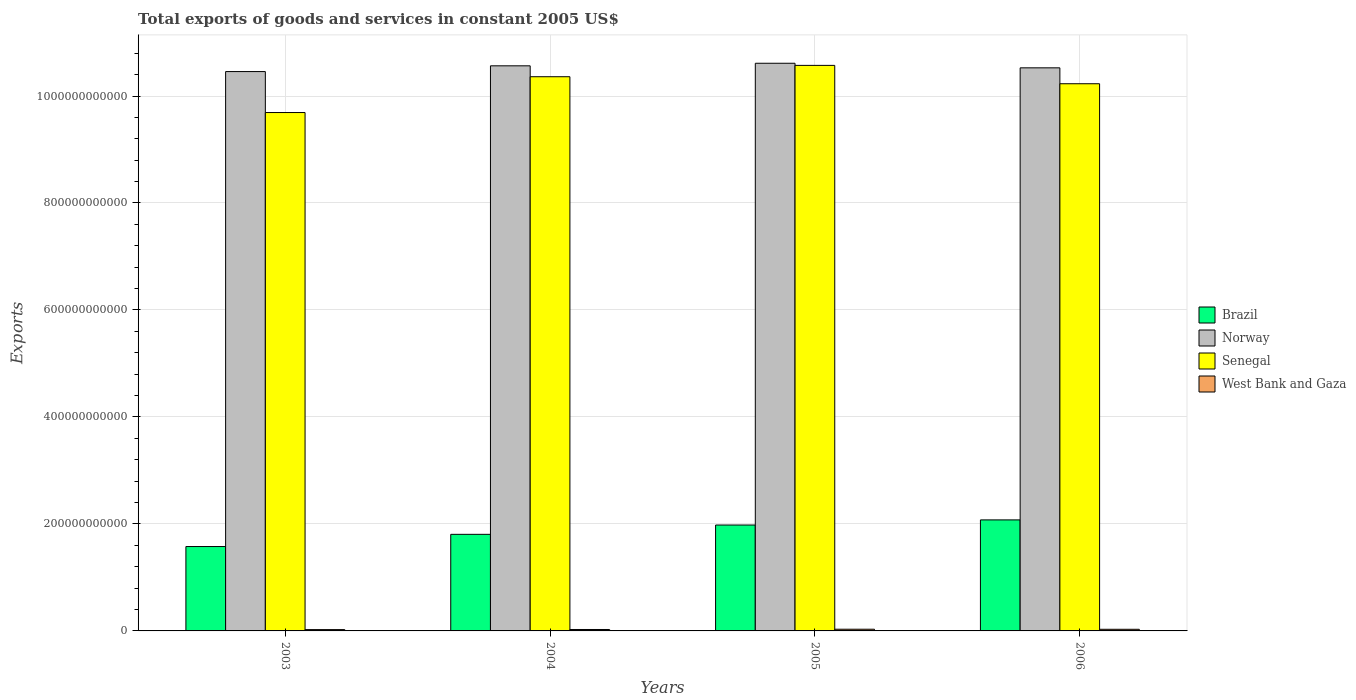How many groups of bars are there?
Give a very brief answer. 4. How many bars are there on the 2nd tick from the left?
Give a very brief answer. 4. How many bars are there on the 1st tick from the right?
Give a very brief answer. 4. What is the total exports of goods and services in Senegal in 2004?
Your response must be concise. 1.04e+12. Across all years, what is the maximum total exports of goods and services in Brazil?
Offer a very short reply. 2.08e+11. Across all years, what is the minimum total exports of goods and services in Brazil?
Keep it short and to the point. 1.58e+11. In which year was the total exports of goods and services in Senegal maximum?
Provide a short and direct response. 2005. What is the total total exports of goods and services in Senegal in the graph?
Provide a short and direct response. 4.09e+12. What is the difference between the total exports of goods and services in Norway in 2003 and that in 2004?
Keep it short and to the point. -1.08e+1. What is the difference between the total exports of goods and services in Norway in 2005 and the total exports of goods and services in Brazil in 2004?
Your answer should be very brief. 8.81e+11. What is the average total exports of goods and services in Brazil per year?
Your response must be concise. 1.86e+11. In the year 2006, what is the difference between the total exports of goods and services in Brazil and total exports of goods and services in West Bank and Gaza?
Make the answer very short. 2.05e+11. What is the ratio of the total exports of goods and services in Norway in 2003 to that in 2005?
Ensure brevity in your answer.  0.99. What is the difference between the highest and the second highest total exports of goods and services in Brazil?
Your response must be concise. 9.58e+09. What is the difference between the highest and the lowest total exports of goods and services in Norway?
Give a very brief answer. 1.55e+1. Is it the case that in every year, the sum of the total exports of goods and services in West Bank and Gaza and total exports of goods and services in Brazil is greater than the sum of total exports of goods and services in Norway and total exports of goods and services in Senegal?
Your answer should be compact. Yes. What does the 3rd bar from the right in 2003 represents?
Your response must be concise. Norway. What is the difference between two consecutive major ticks on the Y-axis?
Keep it short and to the point. 2.00e+11. Are the values on the major ticks of Y-axis written in scientific E-notation?
Your response must be concise. No. Does the graph contain any zero values?
Offer a terse response. No. Does the graph contain grids?
Your response must be concise. Yes. How many legend labels are there?
Offer a terse response. 4. How are the legend labels stacked?
Your response must be concise. Vertical. What is the title of the graph?
Make the answer very short. Total exports of goods and services in constant 2005 US$. Does "Isle of Man" appear as one of the legend labels in the graph?
Offer a terse response. No. What is the label or title of the X-axis?
Ensure brevity in your answer.  Years. What is the label or title of the Y-axis?
Your response must be concise. Exports. What is the Exports of Brazil in 2003?
Offer a very short reply. 1.58e+11. What is the Exports in Norway in 2003?
Offer a very short reply. 1.05e+12. What is the Exports of Senegal in 2003?
Ensure brevity in your answer.  9.69e+11. What is the Exports of West Bank and Gaza in 2003?
Provide a succinct answer. 2.45e+09. What is the Exports in Brazil in 2004?
Make the answer very short. 1.81e+11. What is the Exports in Norway in 2004?
Your response must be concise. 1.06e+12. What is the Exports of Senegal in 2004?
Provide a succinct answer. 1.04e+12. What is the Exports in West Bank and Gaza in 2004?
Offer a terse response. 2.67e+09. What is the Exports in Brazil in 2005?
Provide a succinct answer. 1.98e+11. What is the Exports in Norway in 2005?
Your answer should be compact. 1.06e+12. What is the Exports of Senegal in 2005?
Make the answer very short. 1.06e+12. What is the Exports of West Bank and Gaza in 2005?
Your response must be concise. 3.16e+09. What is the Exports of Brazil in 2006?
Your response must be concise. 2.08e+11. What is the Exports in Norway in 2006?
Provide a succinct answer. 1.05e+12. What is the Exports in Senegal in 2006?
Ensure brevity in your answer.  1.02e+12. What is the Exports of West Bank and Gaza in 2006?
Offer a terse response. 3.05e+09. Across all years, what is the maximum Exports in Brazil?
Provide a succinct answer. 2.08e+11. Across all years, what is the maximum Exports in Norway?
Make the answer very short. 1.06e+12. Across all years, what is the maximum Exports in Senegal?
Your response must be concise. 1.06e+12. Across all years, what is the maximum Exports of West Bank and Gaza?
Ensure brevity in your answer.  3.16e+09. Across all years, what is the minimum Exports of Brazil?
Offer a terse response. 1.58e+11. Across all years, what is the minimum Exports in Norway?
Your response must be concise. 1.05e+12. Across all years, what is the minimum Exports in Senegal?
Give a very brief answer. 9.69e+11. Across all years, what is the minimum Exports in West Bank and Gaza?
Offer a terse response. 2.45e+09. What is the total Exports of Brazil in the graph?
Your answer should be very brief. 7.44e+11. What is the total Exports of Norway in the graph?
Give a very brief answer. 4.22e+12. What is the total Exports in Senegal in the graph?
Make the answer very short. 4.09e+12. What is the total Exports in West Bank and Gaza in the graph?
Your answer should be very brief. 1.13e+1. What is the difference between the Exports of Brazil in 2003 and that in 2004?
Your answer should be compact. -2.28e+1. What is the difference between the Exports in Norway in 2003 and that in 2004?
Your answer should be very brief. -1.08e+1. What is the difference between the Exports of Senegal in 2003 and that in 2004?
Give a very brief answer. -6.69e+1. What is the difference between the Exports in West Bank and Gaza in 2003 and that in 2004?
Ensure brevity in your answer.  -2.19e+08. What is the difference between the Exports of Brazil in 2003 and that in 2005?
Ensure brevity in your answer.  -4.02e+1. What is the difference between the Exports of Norway in 2003 and that in 2005?
Your response must be concise. -1.55e+1. What is the difference between the Exports of Senegal in 2003 and that in 2005?
Keep it short and to the point. -8.81e+1. What is the difference between the Exports in West Bank and Gaza in 2003 and that in 2005?
Provide a short and direct response. -7.08e+08. What is the difference between the Exports in Brazil in 2003 and that in 2006?
Make the answer very short. -4.98e+1. What is the difference between the Exports of Norway in 2003 and that in 2006?
Offer a terse response. -6.99e+09. What is the difference between the Exports in Senegal in 2003 and that in 2006?
Keep it short and to the point. -5.38e+1. What is the difference between the Exports in West Bank and Gaza in 2003 and that in 2006?
Provide a short and direct response. -5.94e+08. What is the difference between the Exports in Brazil in 2004 and that in 2005?
Your answer should be very brief. -1.74e+1. What is the difference between the Exports of Norway in 2004 and that in 2005?
Provide a short and direct response. -4.78e+09. What is the difference between the Exports in Senegal in 2004 and that in 2005?
Your answer should be compact. -2.12e+1. What is the difference between the Exports in West Bank and Gaza in 2004 and that in 2005?
Make the answer very short. -4.89e+08. What is the difference between the Exports in Brazil in 2004 and that in 2006?
Ensure brevity in your answer.  -2.70e+1. What is the difference between the Exports in Norway in 2004 and that in 2006?
Ensure brevity in your answer.  3.77e+09. What is the difference between the Exports of Senegal in 2004 and that in 2006?
Offer a terse response. 1.31e+1. What is the difference between the Exports in West Bank and Gaza in 2004 and that in 2006?
Your response must be concise. -3.74e+08. What is the difference between the Exports of Brazil in 2005 and that in 2006?
Your response must be concise. -9.58e+09. What is the difference between the Exports in Norway in 2005 and that in 2006?
Make the answer very short. 8.55e+09. What is the difference between the Exports in Senegal in 2005 and that in 2006?
Provide a succinct answer. 3.43e+1. What is the difference between the Exports of West Bank and Gaza in 2005 and that in 2006?
Your response must be concise. 1.15e+08. What is the difference between the Exports in Brazil in 2003 and the Exports in Norway in 2004?
Your answer should be compact. -8.99e+11. What is the difference between the Exports in Brazil in 2003 and the Exports in Senegal in 2004?
Your answer should be very brief. -8.78e+11. What is the difference between the Exports of Brazil in 2003 and the Exports of West Bank and Gaza in 2004?
Make the answer very short. 1.55e+11. What is the difference between the Exports in Norway in 2003 and the Exports in Senegal in 2004?
Offer a very short reply. 9.65e+09. What is the difference between the Exports of Norway in 2003 and the Exports of West Bank and Gaza in 2004?
Your answer should be compact. 1.04e+12. What is the difference between the Exports of Senegal in 2003 and the Exports of West Bank and Gaza in 2004?
Your answer should be very brief. 9.66e+11. What is the difference between the Exports of Brazil in 2003 and the Exports of Norway in 2005?
Ensure brevity in your answer.  -9.03e+11. What is the difference between the Exports of Brazil in 2003 and the Exports of Senegal in 2005?
Make the answer very short. -9.00e+11. What is the difference between the Exports in Brazil in 2003 and the Exports in West Bank and Gaza in 2005?
Your response must be concise. 1.55e+11. What is the difference between the Exports of Norway in 2003 and the Exports of Senegal in 2005?
Ensure brevity in your answer.  -1.16e+1. What is the difference between the Exports in Norway in 2003 and the Exports in West Bank and Gaza in 2005?
Offer a very short reply. 1.04e+12. What is the difference between the Exports in Senegal in 2003 and the Exports in West Bank and Gaza in 2005?
Offer a terse response. 9.66e+11. What is the difference between the Exports of Brazil in 2003 and the Exports of Norway in 2006?
Provide a short and direct response. -8.95e+11. What is the difference between the Exports in Brazil in 2003 and the Exports in Senegal in 2006?
Ensure brevity in your answer.  -8.65e+11. What is the difference between the Exports in Brazil in 2003 and the Exports in West Bank and Gaza in 2006?
Give a very brief answer. 1.55e+11. What is the difference between the Exports of Norway in 2003 and the Exports of Senegal in 2006?
Provide a short and direct response. 2.28e+1. What is the difference between the Exports of Norway in 2003 and the Exports of West Bank and Gaza in 2006?
Your answer should be very brief. 1.04e+12. What is the difference between the Exports in Senegal in 2003 and the Exports in West Bank and Gaza in 2006?
Keep it short and to the point. 9.66e+11. What is the difference between the Exports in Brazil in 2004 and the Exports in Norway in 2005?
Your response must be concise. -8.81e+11. What is the difference between the Exports of Brazil in 2004 and the Exports of Senegal in 2005?
Your answer should be compact. -8.77e+11. What is the difference between the Exports in Brazil in 2004 and the Exports in West Bank and Gaza in 2005?
Ensure brevity in your answer.  1.77e+11. What is the difference between the Exports of Norway in 2004 and the Exports of Senegal in 2005?
Your response must be concise. -8.08e+08. What is the difference between the Exports of Norway in 2004 and the Exports of West Bank and Gaza in 2005?
Give a very brief answer. 1.05e+12. What is the difference between the Exports of Senegal in 2004 and the Exports of West Bank and Gaza in 2005?
Your response must be concise. 1.03e+12. What is the difference between the Exports of Brazil in 2004 and the Exports of Norway in 2006?
Your answer should be very brief. -8.72e+11. What is the difference between the Exports of Brazil in 2004 and the Exports of Senegal in 2006?
Ensure brevity in your answer.  -8.42e+11. What is the difference between the Exports in Brazil in 2004 and the Exports in West Bank and Gaza in 2006?
Provide a succinct answer. 1.78e+11. What is the difference between the Exports in Norway in 2004 and the Exports in Senegal in 2006?
Your answer should be compact. 3.35e+1. What is the difference between the Exports in Norway in 2004 and the Exports in West Bank and Gaza in 2006?
Keep it short and to the point. 1.05e+12. What is the difference between the Exports of Senegal in 2004 and the Exports of West Bank and Gaza in 2006?
Offer a very short reply. 1.03e+12. What is the difference between the Exports in Brazil in 2005 and the Exports in Norway in 2006?
Provide a succinct answer. -8.55e+11. What is the difference between the Exports of Brazil in 2005 and the Exports of Senegal in 2006?
Your response must be concise. -8.25e+11. What is the difference between the Exports of Brazil in 2005 and the Exports of West Bank and Gaza in 2006?
Your answer should be very brief. 1.95e+11. What is the difference between the Exports in Norway in 2005 and the Exports in Senegal in 2006?
Your response must be concise. 3.83e+1. What is the difference between the Exports in Norway in 2005 and the Exports in West Bank and Gaza in 2006?
Your answer should be very brief. 1.06e+12. What is the difference between the Exports in Senegal in 2005 and the Exports in West Bank and Gaza in 2006?
Provide a short and direct response. 1.05e+12. What is the average Exports of Brazil per year?
Your answer should be compact. 1.86e+11. What is the average Exports of Norway per year?
Provide a succinct answer. 1.05e+12. What is the average Exports in Senegal per year?
Keep it short and to the point. 1.02e+12. What is the average Exports in West Bank and Gaza per year?
Your answer should be compact. 2.83e+09. In the year 2003, what is the difference between the Exports of Brazil and Exports of Norway?
Your answer should be very brief. -8.88e+11. In the year 2003, what is the difference between the Exports of Brazil and Exports of Senegal?
Ensure brevity in your answer.  -8.11e+11. In the year 2003, what is the difference between the Exports in Brazil and Exports in West Bank and Gaza?
Make the answer very short. 1.55e+11. In the year 2003, what is the difference between the Exports in Norway and Exports in Senegal?
Your response must be concise. 7.66e+1. In the year 2003, what is the difference between the Exports of Norway and Exports of West Bank and Gaza?
Your response must be concise. 1.04e+12. In the year 2003, what is the difference between the Exports in Senegal and Exports in West Bank and Gaza?
Your answer should be compact. 9.67e+11. In the year 2004, what is the difference between the Exports of Brazil and Exports of Norway?
Give a very brief answer. -8.76e+11. In the year 2004, what is the difference between the Exports of Brazil and Exports of Senegal?
Offer a very short reply. -8.55e+11. In the year 2004, what is the difference between the Exports of Brazil and Exports of West Bank and Gaza?
Your answer should be compact. 1.78e+11. In the year 2004, what is the difference between the Exports in Norway and Exports in Senegal?
Provide a succinct answer. 2.04e+1. In the year 2004, what is the difference between the Exports in Norway and Exports in West Bank and Gaza?
Ensure brevity in your answer.  1.05e+12. In the year 2004, what is the difference between the Exports of Senegal and Exports of West Bank and Gaza?
Give a very brief answer. 1.03e+12. In the year 2005, what is the difference between the Exports of Brazil and Exports of Norway?
Your answer should be very brief. -8.63e+11. In the year 2005, what is the difference between the Exports in Brazil and Exports in Senegal?
Offer a terse response. -8.59e+11. In the year 2005, what is the difference between the Exports of Brazil and Exports of West Bank and Gaza?
Offer a terse response. 1.95e+11. In the year 2005, what is the difference between the Exports of Norway and Exports of Senegal?
Give a very brief answer. 3.97e+09. In the year 2005, what is the difference between the Exports in Norway and Exports in West Bank and Gaza?
Your answer should be very brief. 1.06e+12. In the year 2005, what is the difference between the Exports in Senegal and Exports in West Bank and Gaza?
Your response must be concise. 1.05e+12. In the year 2006, what is the difference between the Exports of Brazil and Exports of Norway?
Provide a short and direct response. -8.45e+11. In the year 2006, what is the difference between the Exports in Brazil and Exports in Senegal?
Give a very brief answer. -8.15e+11. In the year 2006, what is the difference between the Exports of Brazil and Exports of West Bank and Gaza?
Keep it short and to the point. 2.05e+11. In the year 2006, what is the difference between the Exports of Norway and Exports of Senegal?
Your response must be concise. 2.97e+1. In the year 2006, what is the difference between the Exports of Norway and Exports of West Bank and Gaza?
Give a very brief answer. 1.05e+12. In the year 2006, what is the difference between the Exports in Senegal and Exports in West Bank and Gaza?
Ensure brevity in your answer.  1.02e+12. What is the ratio of the Exports in Brazil in 2003 to that in 2004?
Your answer should be compact. 0.87. What is the ratio of the Exports in Senegal in 2003 to that in 2004?
Provide a succinct answer. 0.94. What is the ratio of the Exports in West Bank and Gaza in 2003 to that in 2004?
Provide a short and direct response. 0.92. What is the ratio of the Exports in Brazil in 2003 to that in 2005?
Offer a terse response. 0.8. What is the ratio of the Exports of Norway in 2003 to that in 2005?
Give a very brief answer. 0.99. What is the ratio of the Exports in Senegal in 2003 to that in 2005?
Keep it short and to the point. 0.92. What is the ratio of the Exports of West Bank and Gaza in 2003 to that in 2005?
Offer a terse response. 0.78. What is the ratio of the Exports of Brazil in 2003 to that in 2006?
Provide a short and direct response. 0.76. What is the ratio of the Exports in Norway in 2003 to that in 2006?
Give a very brief answer. 0.99. What is the ratio of the Exports of West Bank and Gaza in 2003 to that in 2006?
Your answer should be compact. 0.81. What is the ratio of the Exports in Brazil in 2004 to that in 2005?
Your answer should be very brief. 0.91. What is the ratio of the Exports in Senegal in 2004 to that in 2005?
Make the answer very short. 0.98. What is the ratio of the Exports in West Bank and Gaza in 2004 to that in 2005?
Offer a very short reply. 0.85. What is the ratio of the Exports in Brazil in 2004 to that in 2006?
Your answer should be very brief. 0.87. What is the ratio of the Exports of Senegal in 2004 to that in 2006?
Your response must be concise. 1.01. What is the ratio of the Exports in West Bank and Gaza in 2004 to that in 2006?
Offer a terse response. 0.88. What is the ratio of the Exports of Brazil in 2005 to that in 2006?
Ensure brevity in your answer.  0.95. What is the ratio of the Exports of Norway in 2005 to that in 2006?
Provide a succinct answer. 1.01. What is the ratio of the Exports of Senegal in 2005 to that in 2006?
Provide a succinct answer. 1.03. What is the ratio of the Exports in West Bank and Gaza in 2005 to that in 2006?
Your answer should be very brief. 1.04. What is the difference between the highest and the second highest Exports in Brazil?
Make the answer very short. 9.58e+09. What is the difference between the highest and the second highest Exports in Norway?
Offer a terse response. 4.78e+09. What is the difference between the highest and the second highest Exports in Senegal?
Make the answer very short. 2.12e+1. What is the difference between the highest and the second highest Exports of West Bank and Gaza?
Give a very brief answer. 1.15e+08. What is the difference between the highest and the lowest Exports in Brazil?
Your answer should be very brief. 4.98e+1. What is the difference between the highest and the lowest Exports of Norway?
Provide a succinct answer. 1.55e+1. What is the difference between the highest and the lowest Exports of Senegal?
Your answer should be very brief. 8.81e+1. What is the difference between the highest and the lowest Exports of West Bank and Gaza?
Give a very brief answer. 7.08e+08. 